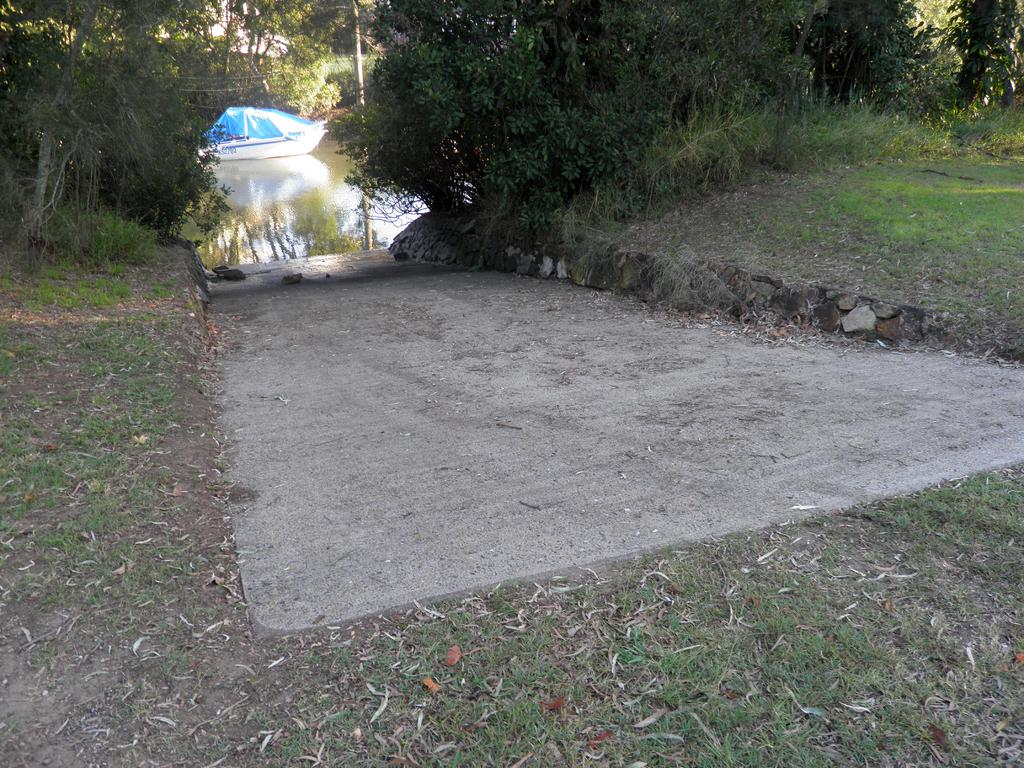What is the main subject of the image? The main subject of the image is a boat. Where is the boat located in the image? The boat is on the water surface in the image. What type of natural environment can be seen in the image? Trees and plants are visible in the image, indicating a natural environment. Can you describe the terrain in the image? There is a slope area visible in the image. What type of meat is being stored in the boat's storage compartment in the image? There is no mention of meat or a storage compartment in the image; it only features a boat on the water surface with trees and plants in the background. 